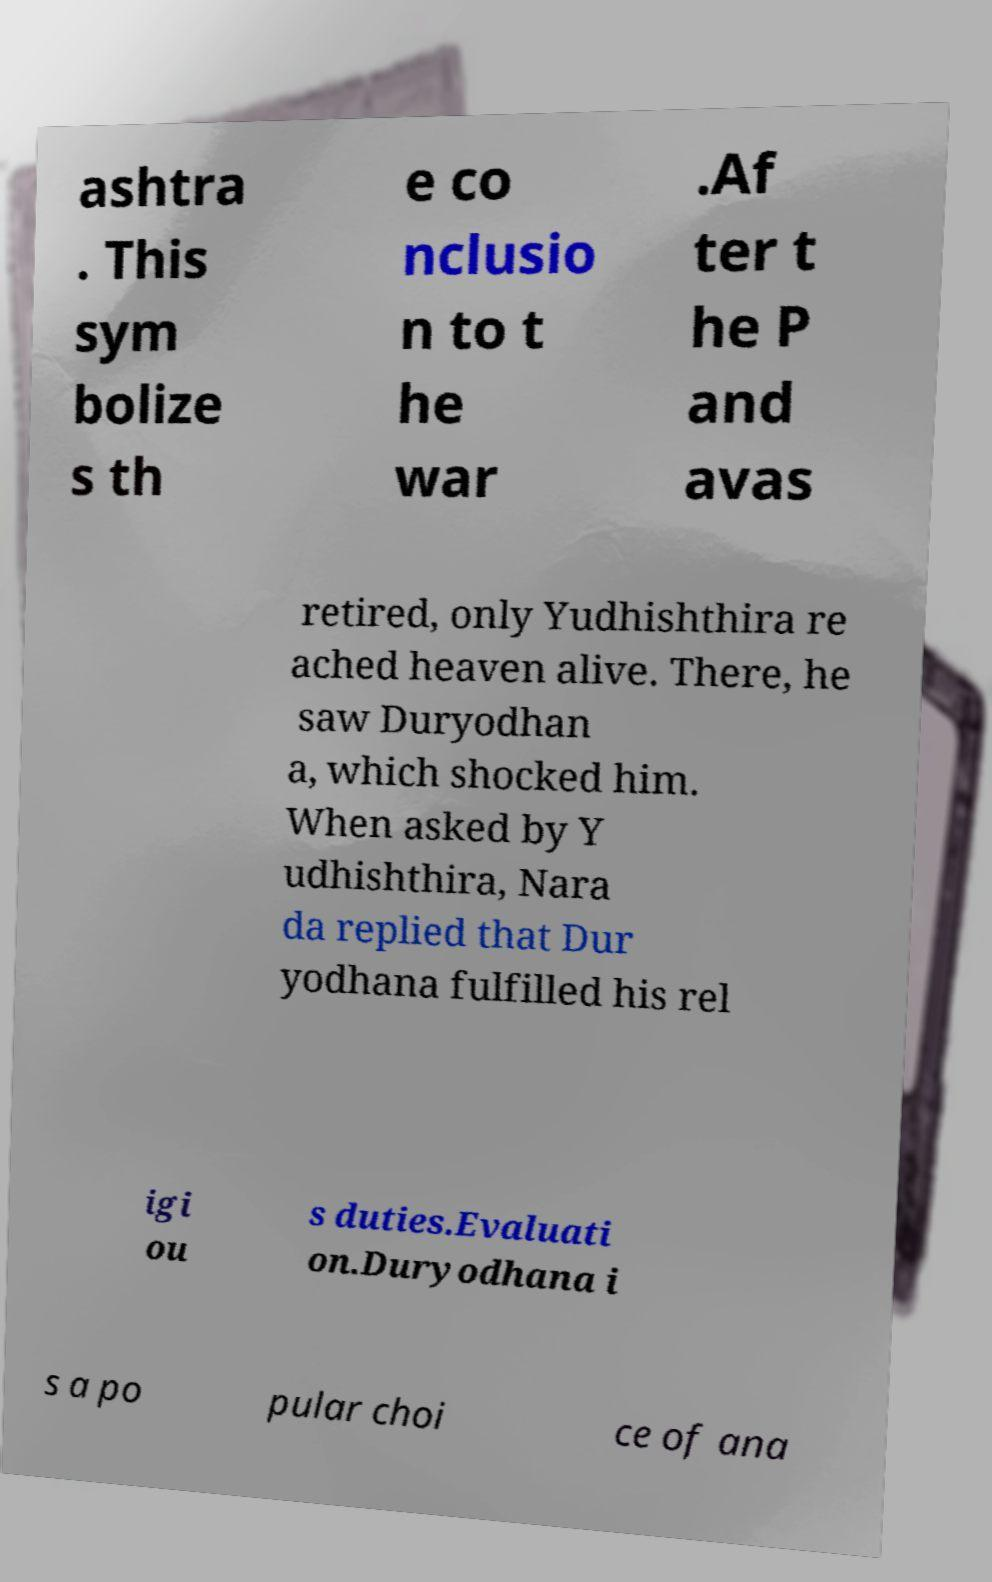For documentation purposes, I need the text within this image transcribed. Could you provide that? ashtra . This sym bolize s th e co nclusio n to t he war .Af ter t he P and avas retired, only Yudhishthira re ached heaven alive. There, he saw Duryodhan a, which shocked him. When asked by Y udhishthira, Nara da replied that Dur yodhana fulfilled his rel igi ou s duties.Evaluati on.Duryodhana i s a po pular choi ce of ana 